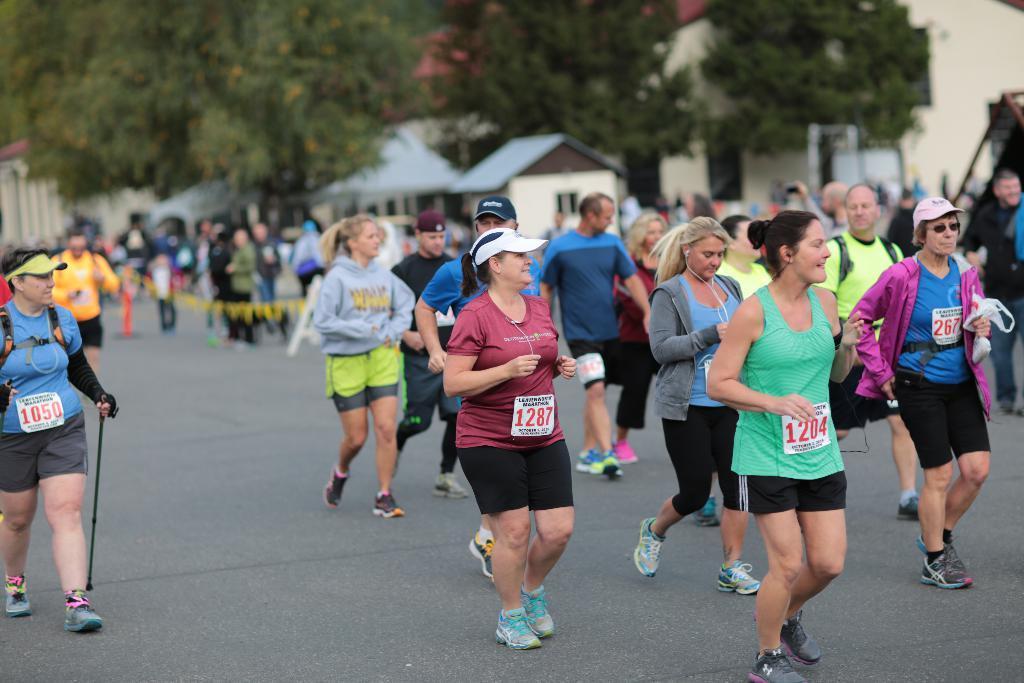How would you summarize this image in a sentence or two? In this image I can see few people are wearing t-shirts, shorts and running towards the right side. On the left side there is a woman is walking by holding a stick on the road. In the background there are some buildings, trees and few people are standing on the road. 